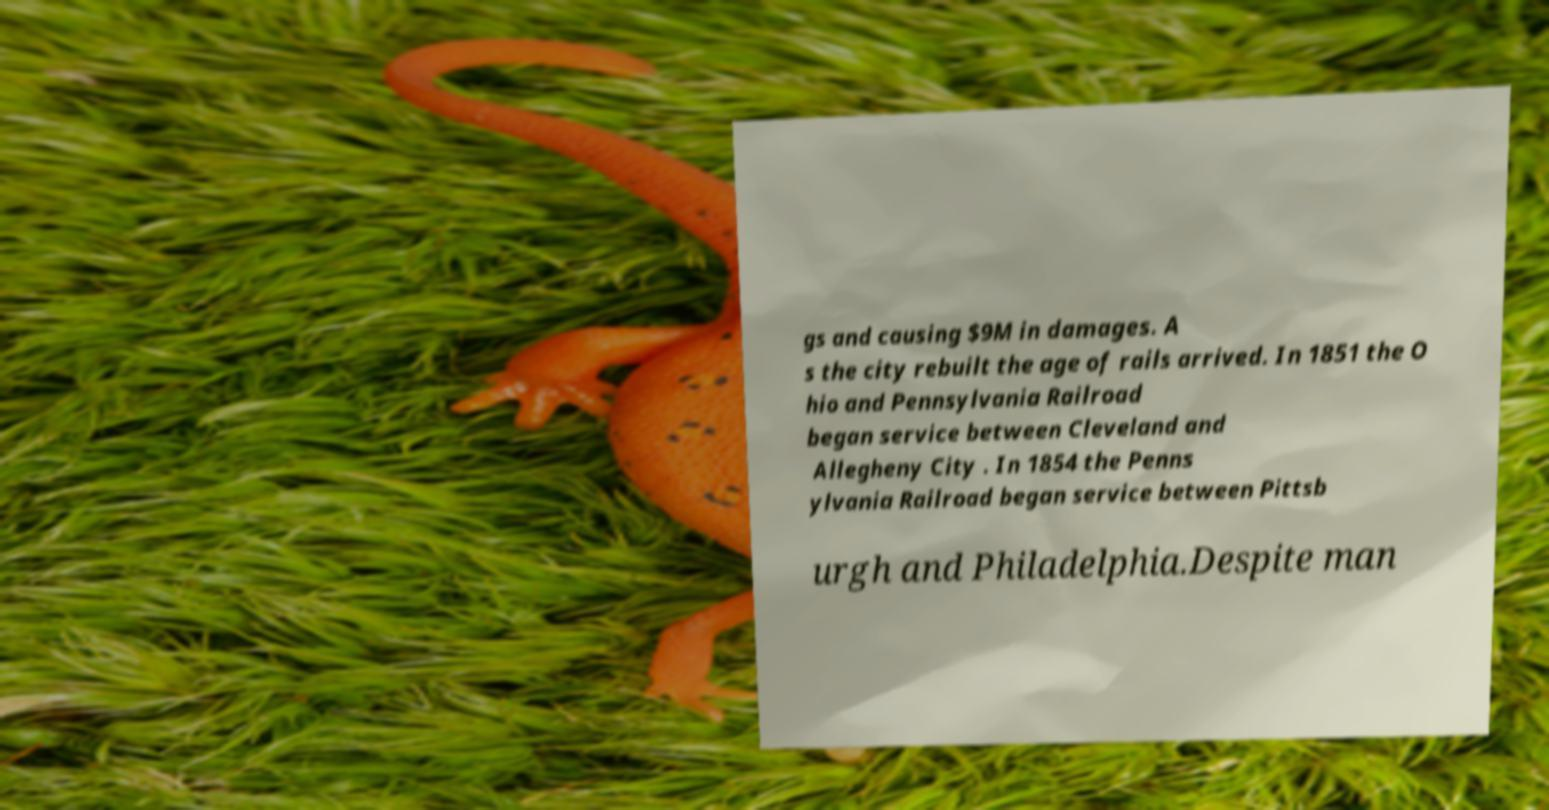What messages or text are displayed in this image? I need them in a readable, typed format. gs and causing $9M in damages. A s the city rebuilt the age of rails arrived. In 1851 the O hio and Pennsylvania Railroad began service between Cleveland and Allegheny City . In 1854 the Penns ylvania Railroad began service between Pittsb urgh and Philadelphia.Despite man 